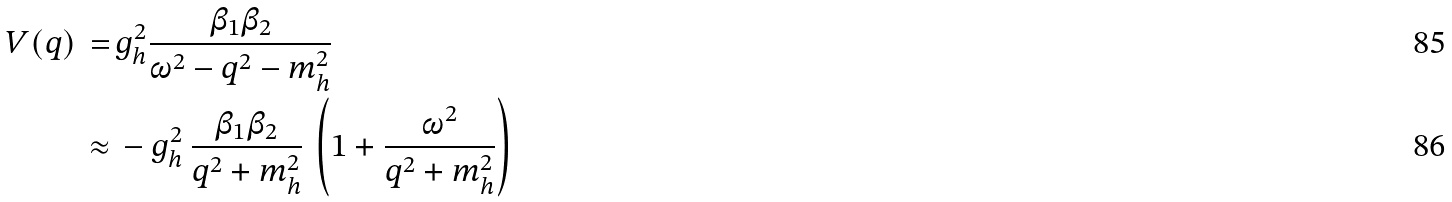<formula> <loc_0><loc_0><loc_500><loc_500>V ( { q } ) \, = \, & g ^ { 2 } _ { h } \frac { \beta _ { 1 } \beta _ { 2 } } { \omega ^ { 2 } - { q } ^ { 2 } - m _ { h } ^ { 2 } } \\ \, \approx \, & - g ^ { 2 } _ { h } \, \frac { \beta _ { 1 } \beta _ { 2 } } { { q } ^ { 2 } + m _ { h } ^ { 2 } } \, \left ( 1 + \frac { \omega ^ { 2 } } { { q } ^ { 2 } + m _ { h } ^ { 2 } } \right )</formula> 